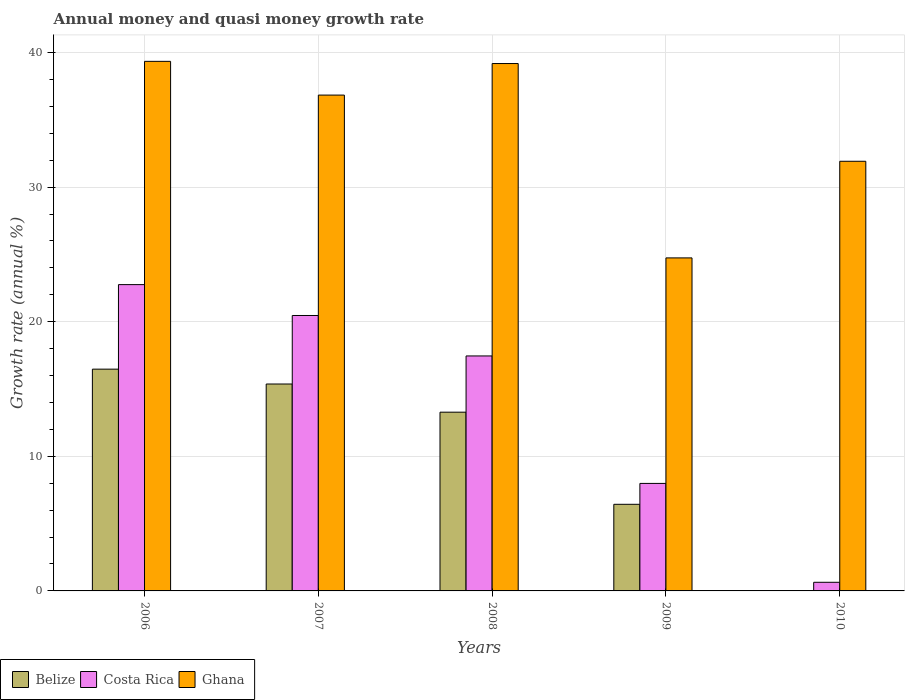How many different coloured bars are there?
Offer a terse response. 3. Are the number of bars per tick equal to the number of legend labels?
Keep it short and to the point. No. In how many cases, is the number of bars for a given year not equal to the number of legend labels?
Your answer should be compact. 1. What is the growth rate in Costa Rica in 2008?
Provide a short and direct response. 17.46. Across all years, what is the maximum growth rate in Costa Rica?
Make the answer very short. 22.76. Across all years, what is the minimum growth rate in Costa Rica?
Your answer should be compact. 0.64. In which year was the growth rate in Belize maximum?
Your answer should be compact. 2006. What is the total growth rate in Ghana in the graph?
Your response must be concise. 172.01. What is the difference between the growth rate in Costa Rica in 2007 and that in 2010?
Make the answer very short. 19.82. What is the difference between the growth rate in Belize in 2009 and the growth rate in Costa Rica in 2006?
Give a very brief answer. -16.32. What is the average growth rate in Belize per year?
Give a very brief answer. 10.31. In the year 2008, what is the difference between the growth rate in Costa Rica and growth rate in Ghana?
Your answer should be very brief. -21.72. What is the ratio of the growth rate in Costa Rica in 2006 to that in 2010?
Make the answer very short. 35.48. Is the difference between the growth rate in Costa Rica in 2007 and 2008 greater than the difference between the growth rate in Ghana in 2007 and 2008?
Your response must be concise. Yes. What is the difference between the highest and the second highest growth rate in Belize?
Make the answer very short. 1.1. What is the difference between the highest and the lowest growth rate in Ghana?
Your answer should be very brief. 14.6. In how many years, is the growth rate in Ghana greater than the average growth rate in Ghana taken over all years?
Your response must be concise. 3. Is the sum of the growth rate in Ghana in 2006 and 2007 greater than the maximum growth rate in Costa Rica across all years?
Ensure brevity in your answer.  Yes. Are all the bars in the graph horizontal?
Provide a short and direct response. No. How many years are there in the graph?
Your answer should be compact. 5. What is the difference between two consecutive major ticks on the Y-axis?
Your answer should be compact. 10. Are the values on the major ticks of Y-axis written in scientific E-notation?
Your answer should be very brief. No. Does the graph contain any zero values?
Offer a terse response. Yes. Does the graph contain grids?
Give a very brief answer. Yes. How are the legend labels stacked?
Give a very brief answer. Horizontal. What is the title of the graph?
Provide a short and direct response. Annual money and quasi money growth rate. What is the label or title of the Y-axis?
Keep it short and to the point. Growth rate (annual %). What is the Growth rate (annual %) in Belize in 2006?
Provide a succinct answer. 16.48. What is the Growth rate (annual %) of Costa Rica in 2006?
Provide a short and direct response. 22.76. What is the Growth rate (annual %) of Ghana in 2006?
Provide a succinct answer. 39.34. What is the Growth rate (annual %) in Belize in 2007?
Ensure brevity in your answer.  15.37. What is the Growth rate (annual %) in Costa Rica in 2007?
Offer a very short reply. 20.46. What is the Growth rate (annual %) of Ghana in 2007?
Offer a very short reply. 36.83. What is the Growth rate (annual %) of Belize in 2008?
Offer a terse response. 13.28. What is the Growth rate (annual %) in Costa Rica in 2008?
Keep it short and to the point. 17.46. What is the Growth rate (annual %) in Ghana in 2008?
Provide a short and direct response. 39.18. What is the Growth rate (annual %) in Belize in 2009?
Offer a very short reply. 6.43. What is the Growth rate (annual %) of Costa Rica in 2009?
Keep it short and to the point. 7.99. What is the Growth rate (annual %) of Ghana in 2009?
Your response must be concise. 24.74. What is the Growth rate (annual %) of Belize in 2010?
Give a very brief answer. 0. What is the Growth rate (annual %) in Costa Rica in 2010?
Make the answer very short. 0.64. What is the Growth rate (annual %) of Ghana in 2010?
Give a very brief answer. 31.92. Across all years, what is the maximum Growth rate (annual %) in Belize?
Your response must be concise. 16.48. Across all years, what is the maximum Growth rate (annual %) in Costa Rica?
Your response must be concise. 22.76. Across all years, what is the maximum Growth rate (annual %) in Ghana?
Provide a succinct answer. 39.34. Across all years, what is the minimum Growth rate (annual %) in Costa Rica?
Provide a succinct answer. 0.64. Across all years, what is the minimum Growth rate (annual %) in Ghana?
Make the answer very short. 24.74. What is the total Growth rate (annual %) in Belize in the graph?
Provide a succinct answer. 51.56. What is the total Growth rate (annual %) in Costa Rica in the graph?
Ensure brevity in your answer.  69.3. What is the total Growth rate (annual %) of Ghana in the graph?
Your answer should be very brief. 172.01. What is the difference between the Growth rate (annual %) of Belize in 2006 and that in 2007?
Offer a terse response. 1.1. What is the difference between the Growth rate (annual %) in Costa Rica in 2006 and that in 2007?
Give a very brief answer. 2.29. What is the difference between the Growth rate (annual %) in Ghana in 2006 and that in 2007?
Offer a terse response. 2.51. What is the difference between the Growth rate (annual %) in Belize in 2006 and that in 2008?
Provide a succinct answer. 3.2. What is the difference between the Growth rate (annual %) in Costa Rica in 2006 and that in 2008?
Make the answer very short. 5.3. What is the difference between the Growth rate (annual %) of Ghana in 2006 and that in 2008?
Your answer should be compact. 0.16. What is the difference between the Growth rate (annual %) in Belize in 2006 and that in 2009?
Your response must be concise. 10.04. What is the difference between the Growth rate (annual %) of Costa Rica in 2006 and that in 2009?
Your answer should be compact. 14.77. What is the difference between the Growth rate (annual %) of Ghana in 2006 and that in 2009?
Keep it short and to the point. 14.6. What is the difference between the Growth rate (annual %) of Costa Rica in 2006 and that in 2010?
Your response must be concise. 22.11. What is the difference between the Growth rate (annual %) of Ghana in 2006 and that in 2010?
Provide a short and direct response. 7.42. What is the difference between the Growth rate (annual %) in Belize in 2007 and that in 2008?
Ensure brevity in your answer.  2.09. What is the difference between the Growth rate (annual %) in Costa Rica in 2007 and that in 2008?
Your response must be concise. 3.01. What is the difference between the Growth rate (annual %) in Ghana in 2007 and that in 2008?
Offer a terse response. -2.34. What is the difference between the Growth rate (annual %) in Belize in 2007 and that in 2009?
Give a very brief answer. 8.94. What is the difference between the Growth rate (annual %) of Costa Rica in 2007 and that in 2009?
Your answer should be compact. 12.47. What is the difference between the Growth rate (annual %) of Ghana in 2007 and that in 2009?
Your answer should be compact. 12.1. What is the difference between the Growth rate (annual %) in Costa Rica in 2007 and that in 2010?
Ensure brevity in your answer.  19.82. What is the difference between the Growth rate (annual %) of Ghana in 2007 and that in 2010?
Ensure brevity in your answer.  4.92. What is the difference between the Growth rate (annual %) in Belize in 2008 and that in 2009?
Your answer should be very brief. 6.84. What is the difference between the Growth rate (annual %) in Costa Rica in 2008 and that in 2009?
Give a very brief answer. 9.47. What is the difference between the Growth rate (annual %) in Ghana in 2008 and that in 2009?
Offer a very short reply. 14.44. What is the difference between the Growth rate (annual %) in Costa Rica in 2008 and that in 2010?
Provide a succinct answer. 16.81. What is the difference between the Growth rate (annual %) in Ghana in 2008 and that in 2010?
Provide a succinct answer. 7.26. What is the difference between the Growth rate (annual %) of Costa Rica in 2009 and that in 2010?
Offer a terse response. 7.35. What is the difference between the Growth rate (annual %) of Ghana in 2009 and that in 2010?
Offer a terse response. -7.18. What is the difference between the Growth rate (annual %) in Belize in 2006 and the Growth rate (annual %) in Costa Rica in 2007?
Provide a succinct answer. -3.99. What is the difference between the Growth rate (annual %) of Belize in 2006 and the Growth rate (annual %) of Ghana in 2007?
Provide a short and direct response. -20.36. What is the difference between the Growth rate (annual %) of Costa Rica in 2006 and the Growth rate (annual %) of Ghana in 2007?
Keep it short and to the point. -14.08. What is the difference between the Growth rate (annual %) in Belize in 2006 and the Growth rate (annual %) in Costa Rica in 2008?
Your response must be concise. -0.98. What is the difference between the Growth rate (annual %) in Belize in 2006 and the Growth rate (annual %) in Ghana in 2008?
Offer a terse response. -22.7. What is the difference between the Growth rate (annual %) of Costa Rica in 2006 and the Growth rate (annual %) of Ghana in 2008?
Your response must be concise. -16.42. What is the difference between the Growth rate (annual %) of Belize in 2006 and the Growth rate (annual %) of Costa Rica in 2009?
Your answer should be compact. 8.49. What is the difference between the Growth rate (annual %) in Belize in 2006 and the Growth rate (annual %) in Ghana in 2009?
Your response must be concise. -8.26. What is the difference between the Growth rate (annual %) in Costa Rica in 2006 and the Growth rate (annual %) in Ghana in 2009?
Offer a terse response. -1.98. What is the difference between the Growth rate (annual %) in Belize in 2006 and the Growth rate (annual %) in Costa Rica in 2010?
Your answer should be compact. 15.83. What is the difference between the Growth rate (annual %) of Belize in 2006 and the Growth rate (annual %) of Ghana in 2010?
Give a very brief answer. -15.44. What is the difference between the Growth rate (annual %) of Costa Rica in 2006 and the Growth rate (annual %) of Ghana in 2010?
Provide a short and direct response. -9.16. What is the difference between the Growth rate (annual %) in Belize in 2007 and the Growth rate (annual %) in Costa Rica in 2008?
Offer a terse response. -2.08. What is the difference between the Growth rate (annual %) in Belize in 2007 and the Growth rate (annual %) in Ghana in 2008?
Ensure brevity in your answer.  -23.81. What is the difference between the Growth rate (annual %) of Costa Rica in 2007 and the Growth rate (annual %) of Ghana in 2008?
Your answer should be compact. -18.72. What is the difference between the Growth rate (annual %) in Belize in 2007 and the Growth rate (annual %) in Costa Rica in 2009?
Your answer should be compact. 7.38. What is the difference between the Growth rate (annual %) in Belize in 2007 and the Growth rate (annual %) in Ghana in 2009?
Your answer should be very brief. -9.37. What is the difference between the Growth rate (annual %) in Costa Rica in 2007 and the Growth rate (annual %) in Ghana in 2009?
Ensure brevity in your answer.  -4.28. What is the difference between the Growth rate (annual %) of Belize in 2007 and the Growth rate (annual %) of Costa Rica in 2010?
Ensure brevity in your answer.  14.73. What is the difference between the Growth rate (annual %) of Belize in 2007 and the Growth rate (annual %) of Ghana in 2010?
Your response must be concise. -16.55. What is the difference between the Growth rate (annual %) of Costa Rica in 2007 and the Growth rate (annual %) of Ghana in 2010?
Your answer should be compact. -11.46. What is the difference between the Growth rate (annual %) in Belize in 2008 and the Growth rate (annual %) in Costa Rica in 2009?
Your answer should be very brief. 5.29. What is the difference between the Growth rate (annual %) of Belize in 2008 and the Growth rate (annual %) of Ghana in 2009?
Offer a very short reply. -11.46. What is the difference between the Growth rate (annual %) of Costa Rica in 2008 and the Growth rate (annual %) of Ghana in 2009?
Ensure brevity in your answer.  -7.28. What is the difference between the Growth rate (annual %) in Belize in 2008 and the Growth rate (annual %) in Costa Rica in 2010?
Offer a very short reply. 12.64. What is the difference between the Growth rate (annual %) in Belize in 2008 and the Growth rate (annual %) in Ghana in 2010?
Provide a succinct answer. -18.64. What is the difference between the Growth rate (annual %) in Costa Rica in 2008 and the Growth rate (annual %) in Ghana in 2010?
Your answer should be very brief. -14.46. What is the difference between the Growth rate (annual %) in Belize in 2009 and the Growth rate (annual %) in Costa Rica in 2010?
Give a very brief answer. 5.79. What is the difference between the Growth rate (annual %) of Belize in 2009 and the Growth rate (annual %) of Ghana in 2010?
Your answer should be very brief. -25.48. What is the difference between the Growth rate (annual %) of Costa Rica in 2009 and the Growth rate (annual %) of Ghana in 2010?
Ensure brevity in your answer.  -23.93. What is the average Growth rate (annual %) in Belize per year?
Provide a short and direct response. 10.31. What is the average Growth rate (annual %) of Costa Rica per year?
Ensure brevity in your answer.  13.86. What is the average Growth rate (annual %) in Ghana per year?
Offer a terse response. 34.4. In the year 2006, what is the difference between the Growth rate (annual %) in Belize and Growth rate (annual %) in Costa Rica?
Offer a terse response. -6.28. In the year 2006, what is the difference between the Growth rate (annual %) in Belize and Growth rate (annual %) in Ghana?
Make the answer very short. -22.87. In the year 2006, what is the difference between the Growth rate (annual %) in Costa Rica and Growth rate (annual %) in Ghana?
Your answer should be compact. -16.59. In the year 2007, what is the difference between the Growth rate (annual %) in Belize and Growth rate (annual %) in Costa Rica?
Offer a very short reply. -5.09. In the year 2007, what is the difference between the Growth rate (annual %) in Belize and Growth rate (annual %) in Ghana?
Make the answer very short. -21.46. In the year 2007, what is the difference between the Growth rate (annual %) in Costa Rica and Growth rate (annual %) in Ghana?
Make the answer very short. -16.37. In the year 2008, what is the difference between the Growth rate (annual %) in Belize and Growth rate (annual %) in Costa Rica?
Offer a terse response. -4.18. In the year 2008, what is the difference between the Growth rate (annual %) of Belize and Growth rate (annual %) of Ghana?
Keep it short and to the point. -25.9. In the year 2008, what is the difference between the Growth rate (annual %) in Costa Rica and Growth rate (annual %) in Ghana?
Give a very brief answer. -21.72. In the year 2009, what is the difference between the Growth rate (annual %) in Belize and Growth rate (annual %) in Costa Rica?
Keep it short and to the point. -1.55. In the year 2009, what is the difference between the Growth rate (annual %) of Belize and Growth rate (annual %) of Ghana?
Keep it short and to the point. -18.3. In the year 2009, what is the difference between the Growth rate (annual %) in Costa Rica and Growth rate (annual %) in Ghana?
Offer a terse response. -16.75. In the year 2010, what is the difference between the Growth rate (annual %) of Costa Rica and Growth rate (annual %) of Ghana?
Make the answer very short. -31.28. What is the ratio of the Growth rate (annual %) of Belize in 2006 to that in 2007?
Your response must be concise. 1.07. What is the ratio of the Growth rate (annual %) in Costa Rica in 2006 to that in 2007?
Offer a terse response. 1.11. What is the ratio of the Growth rate (annual %) of Ghana in 2006 to that in 2007?
Provide a short and direct response. 1.07. What is the ratio of the Growth rate (annual %) of Belize in 2006 to that in 2008?
Provide a short and direct response. 1.24. What is the ratio of the Growth rate (annual %) in Costa Rica in 2006 to that in 2008?
Your answer should be very brief. 1.3. What is the ratio of the Growth rate (annual %) in Belize in 2006 to that in 2009?
Keep it short and to the point. 2.56. What is the ratio of the Growth rate (annual %) of Costa Rica in 2006 to that in 2009?
Your answer should be compact. 2.85. What is the ratio of the Growth rate (annual %) of Ghana in 2006 to that in 2009?
Provide a short and direct response. 1.59. What is the ratio of the Growth rate (annual %) in Costa Rica in 2006 to that in 2010?
Keep it short and to the point. 35.48. What is the ratio of the Growth rate (annual %) in Ghana in 2006 to that in 2010?
Provide a short and direct response. 1.23. What is the ratio of the Growth rate (annual %) of Belize in 2007 to that in 2008?
Offer a very short reply. 1.16. What is the ratio of the Growth rate (annual %) of Costa Rica in 2007 to that in 2008?
Offer a very short reply. 1.17. What is the ratio of the Growth rate (annual %) in Ghana in 2007 to that in 2008?
Provide a short and direct response. 0.94. What is the ratio of the Growth rate (annual %) in Belize in 2007 to that in 2009?
Provide a succinct answer. 2.39. What is the ratio of the Growth rate (annual %) in Costa Rica in 2007 to that in 2009?
Keep it short and to the point. 2.56. What is the ratio of the Growth rate (annual %) in Ghana in 2007 to that in 2009?
Provide a short and direct response. 1.49. What is the ratio of the Growth rate (annual %) of Costa Rica in 2007 to that in 2010?
Offer a terse response. 31.9. What is the ratio of the Growth rate (annual %) in Ghana in 2007 to that in 2010?
Give a very brief answer. 1.15. What is the ratio of the Growth rate (annual %) in Belize in 2008 to that in 2009?
Keep it short and to the point. 2.06. What is the ratio of the Growth rate (annual %) in Costa Rica in 2008 to that in 2009?
Your answer should be compact. 2.19. What is the ratio of the Growth rate (annual %) of Ghana in 2008 to that in 2009?
Provide a short and direct response. 1.58. What is the ratio of the Growth rate (annual %) of Costa Rica in 2008 to that in 2010?
Your answer should be very brief. 27.21. What is the ratio of the Growth rate (annual %) in Ghana in 2008 to that in 2010?
Your response must be concise. 1.23. What is the ratio of the Growth rate (annual %) in Costa Rica in 2009 to that in 2010?
Ensure brevity in your answer.  12.45. What is the ratio of the Growth rate (annual %) of Ghana in 2009 to that in 2010?
Ensure brevity in your answer.  0.78. What is the difference between the highest and the second highest Growth rate (annual %) of Belize?
Give a very brief answer. 1.1. What is the difference between the highest and the second highest Growth rate (annual %) of Costa Rica?
Provide a succinct answer. 2.29. What is the difference between the highest and the second highest Growth rate (annual %) of Ghana?
Provide a succinct answer. 0.16. What is the difference between the highest and the lowest Growth rate (annual %) in Belize?
Provide a succinct answer. 16.48. What is the difference between the highest and the lowest Growth rate (annual %) of Costa Rica?
Offer a terse response. 22.11. What is the difference between the highest and the lowest Growth rate (annual %) in Ghana?
Provide a short and direct response. 14.6. 